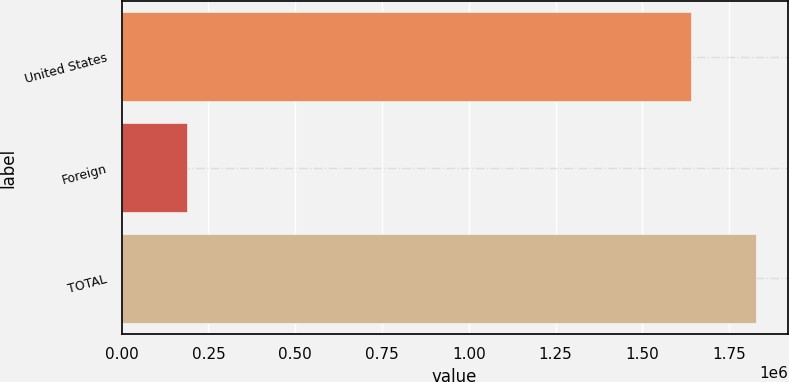<chart> <loc_0><loc_0><loc_500><loc_500><bar_chart><fcel>United States<fcel>Foreign<fcel>TOTAL<nl><fcel>1.63926e+06<fcel>188196<fcel>1.82745e+06<nl></chart> 